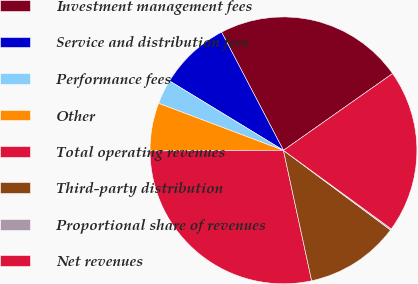Convert chart to OTSL. <chart><loc_0><loc_0><loc_500><loc_500><pie_chart><fcel>Investment management fees<fcel>Service and distribution fees<fcel>Performance fees<fcel>Other<fcel>Total operating revenues<fcel>Third-party distribution<fcel>Proportional share of revenues<fcel>Net revenues<nl><fcel>22.92%<fcel>8.61%<fcel>2.98%<fcel>5.8%<fcel>28.32%<fcel>11.43%<fcel>0.16%<fcel>19.78%<nl></chart> 